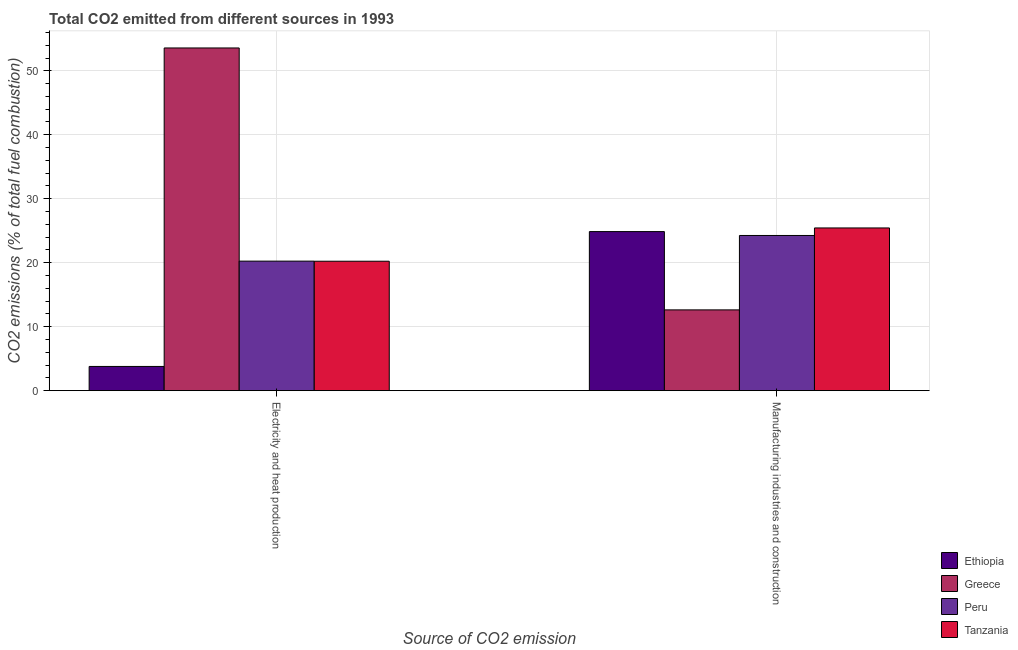Are the number of bars per tick equal to the number of legend labels?
Your response must be concise. Yes. Are the number of bars on each tick of the X-axis equal?
Keep it short and to the point. Yes. What is the label of the 2nd group of bars from the left?
Give a very brief answer. Manufacturing industries and construction. What is the co2 emissions due to manufacturing industries in Greece?
Your response must be concise. 12.63. Across all countries, what is the maximum co2 emissions due to manufacturing industries?
Provide a succinct answer. 25.43. Across all countries, what is the minimum co2 emissions due to electricity and heat production?
Keep it short and to the point. 3.78. In which country was the co2 emissions due to manufacturing industries maximum?
Provide a succinct answer. Tanzania. In which country was the co2 emissions due to manufacturing industries minimum?
Offer a terse response. Greece. What is the total co2 emissions due to electricity and heat production in the graph?
Your response must be concise. 97.83. What is the difference between the co2 emissions due to manufacturing industries in Ethiopia and that in Peru?
Your response must be concise. 0.61. What is the difference between the co2 emissions due to manufacturing industries in Tanzania and the co2 emissions due to electricity and heat production in Greece?
Make the answer very short. -28.14. What is the average co2 emissions due to manufacturing industries per country?
Keep it short and to the point. 21.8. What is the difference between the co2 emissions due to manufacturing industries and co2 emissions due to electricity and heat production in Greece?
Offer a very short reply. -40.95. What is the ratio of the co2 emissions due to manufacturing industries in Ethiopia to that in Tanzania?
Offer a terse response. 0.98. What does the 3rd bar from the left in Manufacturing industries and construction represents?
Give a very brief answer. Peru. What does the 1st bar from the right in Manufacturing industries and construction represents?
Your answer should be very brief. Tanzania. How many bars are there?
Keep it short and to the point. 8. Are all the bars in the graph horizontal?
Provide a succinct answer. No. Where does the legend appear in the graph?
Your answer should be very brief. Bottom right. How many legend labels are there?
Ensure brevity in your answer.  4. What is the title of the graph?
Your response must be concise. Total CO2 emitted from different sources in 1993. Does "Malta" appear as one of the legend labels in the graph?
Offer a terse response. No. What is the label or title of the X-axis?
Your answer should be very brief. Source of CO2 emission. What is the label or title of the Y-axis?
Provide a short and direct response. CO2 emissions (% of total fuel combustion). What is the CO2 emissions (% of total fuel combustion) of Ethiopia in Electricity and heat production?
Provide a succinct answer. 3.78. What is the CO2 emissions (% of total fuel combustion) of Greece in Electricity and heat production?
Offer a terse response. 53.57. What is the CO2 emissions (% of total fuel combustion) in Peru in Electricity and heat production?
Give a very brief answer. 20.25. What is the CO2 emissions (% of total fuel combustion) in Tanzania in Electricity and heat production?
Your answer should be very brief. 20.23. What is the CO2 emissions (% of total fuel combustion) in Ethiopia in Manufacturing industries and construction?
Offer a terse response. 24.86. What is the CO2 emissions (% of total fuel combustion) in Greece in Manufacturing industries and construction?
Keep it short and to the point. 12.63. What is the CO2 emissions (% of total fuel combustion) of Peru in Manufacturing industries and construction?
Offer a very short reply. 24.26. What is the CO2 emissions (% of total fuel combustion) of Tanzania in Manufacturing industries and construction?
Your response must be concise. 25.43. Across all Source of CO2 emission, what is the maximum CO2 emissions (% of total fuel combustion) in Ethiopia?
Keep it short and to the point. 24.86. Across all Source of CO2 emission, what is the maximum CO2 emissions (% of total fuel combustion) of Greece?
Keep it short and to the point. 53.57. Across all Source of CO2 emission, what is the maximum CO2 emissions (% of total fuel combustion) in Peru?
Your response must be concise. 24.26. Across all Source of CO2 emission, what is the maximum CO2 emissions (% of total fuel combustion) of Tanzania?
Provide a succinct answer. 25.43. Across all Source of CO2 emission, what is the minimum CO2 emissions (% of total fuel combustion) in Ethiopia?
Give a very brief answer. 3.78. Across all Source of CO2 emission, what is the minimum CO2 emissions (% of total fuel combustion) in Greece?
Provide a short and direct response. 12.63. Across all Source of CO2 emission, what is the minimum CO2 emissions (% of total fuel combustion) in Peru?
Make the answer very short. 20.25. Across all Source of CO2 emission, what is the minimum CO2 emissions (% of total fuel combustion) in Tanzania?
Give a very brief answer. 20.23. What is the total CO2 emissions (% of total fuel combustion) of Ethiopia in the graph?
Offer a terse response. 28.65. What is the total CO2 emissions (% of total fuel combustion) of Greece in the graph?
Make the answer very short. 66.2. What is the total CO2 emissions (% of total fuel combustion) of Peru in the graph?
Your answer should be very brief. 44.51. What is the total CO2 emissions (% of total fuel combustion) of Tanzania in the graph?
Provide a short and direct response. 45.66. What is the difference between the CO2 emissions (% of total fuel combustion) of Ethiopia in Electricity and heat production and that in Manufacturing industries and construction?
Give a very brief answer. -21.08. What is the difference between the CO2 emissions (% of total fuel combustion) of Greece in Electricity and heat production and that in Manufacturing industries and construction?
Your response must be concise. 40.95. What is the difference between the CO2 emissions (% of total fuel combustion) in Peru in Electricity and heat production and that in Manufacturing industries and construction?
Your answer should be very brief. -4.01. What is the difference between the CO2 emissions (% of total fuel combustion) of Tanzania in Electricity and heat production and that in Manufacturing industries and construction?
Your answer should be compact. -5.2. What is the difference between the CO2 emissions (% of total fuel combustion) of Ethiopia in Electricity and heat production and the CO2 emissions (% of total fuel combustion) of Greece in Manufacturing industries and construction?
Make the answer very short. -8.84. What is the difference between the CO2 emissions (% of total fuel combustion) of Ethiopia in Electricity and heat production and the CO2 emissions (% of total fuel combustion) of Peru in Manufacturing industries and construction?
Make the answer very short. -20.47. What is the difference between the CO2 emissions (% of total fuel combustion) of Ethiopia in Electricity and heat production and the CO2 emissions (% of total fuel combustion) of Tanzania in Manufacturing industries and construction?
Ensure brevity in your answer.  -21.65. What is the difference between the CO2 emissions (% of total fuel combustion) in Greece in Electricity and heat production and the CO2 emissions (% of total fuel combustion) in Peru in Manufacturing industries and construction?
Give a very brief answer. 29.31. What is the difference between the CO2 emissions (% of total fuel combustion) in Greece in Electricity and heat production and the CO2 emissions (% of total fuel combustion) in Tanzania in Manufacturing industries and construction?
Offer a very short reply. 28.14. What is the difference between the CO2 emissions (% of total fuel combustion) in Peru in Electricity and heat production and the CO2 emissions (% of total fuel combustion) in Tanzania in Manufacturing industries and construction?
Provide a short and direct response. -5.19. What is the average CO2 emissions (% of total fuel combustion) of Ethiopia per Source of CO2 emission?
Offer a terse response. 14.32. What is the average CO2 emissions (% of total fuel combustion) in Greece per Source of CO2 emission?
Keep it short and to the point. 33.1. What is the average CO2 emissions (% of total fuel combustion) of Peru per Source of CO2 emission?
Give a very brief answer. 22.25. What is the average CO2 emissions (% of total fuel combustion) of Tanzania per Source of CO2 emission?
Your answer should be compact. 22.83. What is the difference between the CO2 emissions (% of total fuel combustion) of Ethiopia and CO2 emissions (% of total fuel combustion) of Greece in Electricity and heat production?
Offer a very short reply. -49.79. What is the difference between the CO2 emissions (% of total fuel combustion) of Ethiopia and CO2 emissions (% of total fuel combustion) of Peru in Electricity and heat production?
Offer a very short reply. -16.46. What is the difference between the CO2 emissions (% of total fuel combustion) in Ethiopia and CO2 emissions (% of total fuel combustion) in Tanzania in Electricity and heat production?
Offer a very short reply. -16.45. What is the difference between the CO2 emissions (% of total fuel combustion) of Greece and CO2 emissions (% of total fuel combustion) of Peru in Electricity and heat production?
Keep it short and to the point. 33.32. What is the difference between the CO2 emissions (% of total fuel combustion) of Greece and CO2 emissions (% of total fuel combustion) of Tanzania in Electricity and heat production?
Keep it short and to the point. 33.34. What is the difference between the CO2 emissions (% of total fuel combustion) in Peru and CO2 emissions (% of total fuel combustion) in Tanzania in Electricity and heat production?
Your answer should be very brief. 0.02. What is the difference between the CO2 emissions (% of total fuel combustion) of Ethiopia and CO2 emissions (% of total fuel combustion) of Greece in Manufacturing industries and construction?
Your answer should be very brief. 12.24. What is the difference between the CO2 emissions (% of total fuel combustion) in Ethiopia and CO2 emissions (% of total fuel combustion) in Peru in Manufacturing industries and construction?
Offer a very short reply. 0.61. What is the difference between the CO2 emissions (% of total fuel combustion) in Ethiopia and CO2 emissions (% of total fuel combustion) in Tanzania in Manufacturing industries and construction?
Provide a succinct answer. -0.57. What is the difference between the CO2 emissions (% of total fuel combustion) of Greece and CO2 emissions (% of total fuel combustion) of Peru in Manufacturing industries and construction?
Your answer should be very brief. -11.63. What is the difference between the CO2 emissions (% of total fuel combustion) of Greece and CO2 emissions (% of total fuel combustion) of Tanzania in Manufacturing industries and construction?
Your answer should be very brief. -12.81. What is the difference between the CO2 emissions (% of total fuel combustion) in Peru and CO2 emissions (% of total fuel combustion) in Tanzania in Manufacturing industries and construction?
Offer a terse response. -1.18. What is the ratio of the CO2 emissions (% of total fuel combustion) of Ethiopia in Electricity and heat production to that in Manufacturing industries and construction?
Your response must be concise. 0.15. What is the ratio of the CO2 emissions (% of total fuel combustion) of Greece in Electricity and heat production to that in Manufacturing industries and construction?
Make the answer very short. 4.24. What is the ratio of the CO2 emissions (% of total fuel combustion) of Peru in Electricity and heat production to that in Manufacturing industries and construction?
Ensure brevity in your answer.  0.83. What is the ratio of the CO2 emissions (% of total fuel combustion) of Tanzania in Electricity and heat production to that in Manufacturing industries and construction?
Keep it short and to the point. 0.8. What is the difference between the highest and the second highest CO2 emissions (% of total fuel combustion) of Ethiopia?
Offer a very short reply. 21.08. What is the difference between the highest and the second highest CO2 emissions (% of total fuel combustion) in Greece?
Your answer should be compact. 40.95. What is the difference between the highest and the second highest CO2 emissions (% of total fuel combustion) of Peru?
Your response must be concise. 4.01. What is the difference between the highest and the second highest CO2 emissions (% of total fuel combustion) in Tanzania?
Provide a succinct answer. 5.2. What is the difference between the highest and the lowest CO2 emissions (% of total fuel combustion) of Ethiopia?
Provide a short and direct response. 21.08. What is the difference between the highest and the lowest CO2 emissions (% of total fuel combustion) in Greece?
Provide a short and direct response. 40.95. What is the difference between the highest and the lowest CO2 emissions (% of total fuel combustion) of Peru?
Give a very brief answer. 4.01. What is the difference between the highest and the lowest CO2 emissions (% of total fuel combustion) in Tanzania?
Provide a succinct answer. 5.2. 